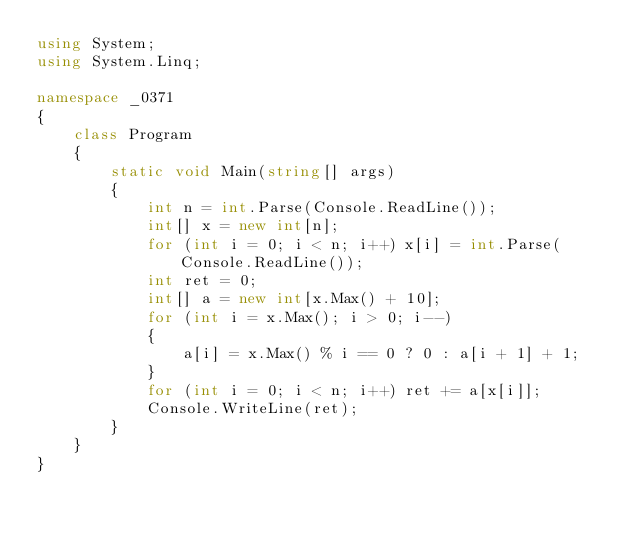Convert code to text. <code><loc_0><loc_0><loc_500><loc_500><_C#_>using System;
using System.Linq;

namespace _0371
{
    class Program
    {
        static void Main(string[] args)
        {
            int n = int.Parse(Console.ReadLine());
            int[] x = new int[n];
            for (int i = 0; i < n; i++) x[i] = int.Parse(Console.ReadLine());
            int ret = 0;
            int[] a = new int[x.Max() + 10];
            for (int i = x.Max(); i > 0; i--)
            {
                a[i] = x.Max() % i == 0 ? 0 : a[i + 1] + 1;
            }
            for (int i = 0; i < n; i++) ret += a[x[i]];
            Console.WriteLine(ret);
        }
    }
}
</code> 